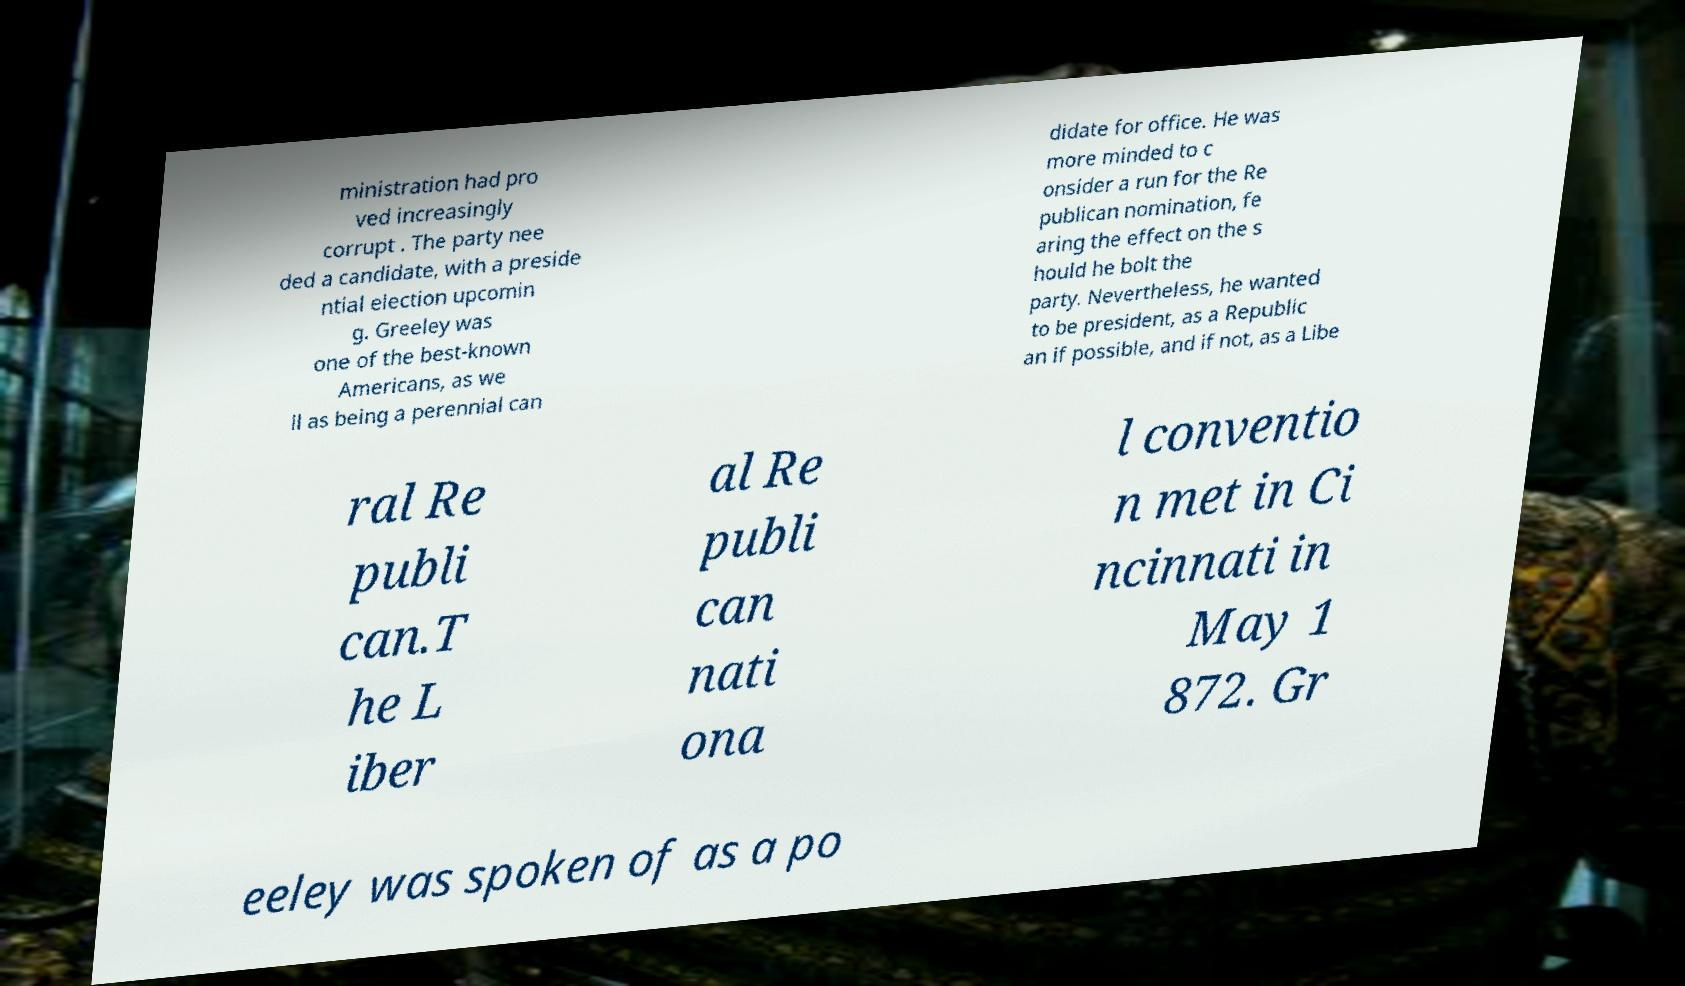Can you read and provide the text displayed in the image?This photo seems to have some interesting text. Can you extract and type it out for me? ministration had pro ved increasingly corrupt . The party nee ded a candidate, with a preside ntial election upcomin g. Greeley was one of the best-known Americans, as we ll as being a perennial can didate for office. He was more minded to c onsider a run for the Re publican nomination, fe aring the effect on the s hould he bolt the party. Nevertheless, he wanted to be president, as a Republic an if possible, and if not, as a Libe ral Re publi can.T he L iber al Re publi can nati ona l conventio n met in Ci ncinnati in May 1 872. Gr eeley was spoken of as a po 